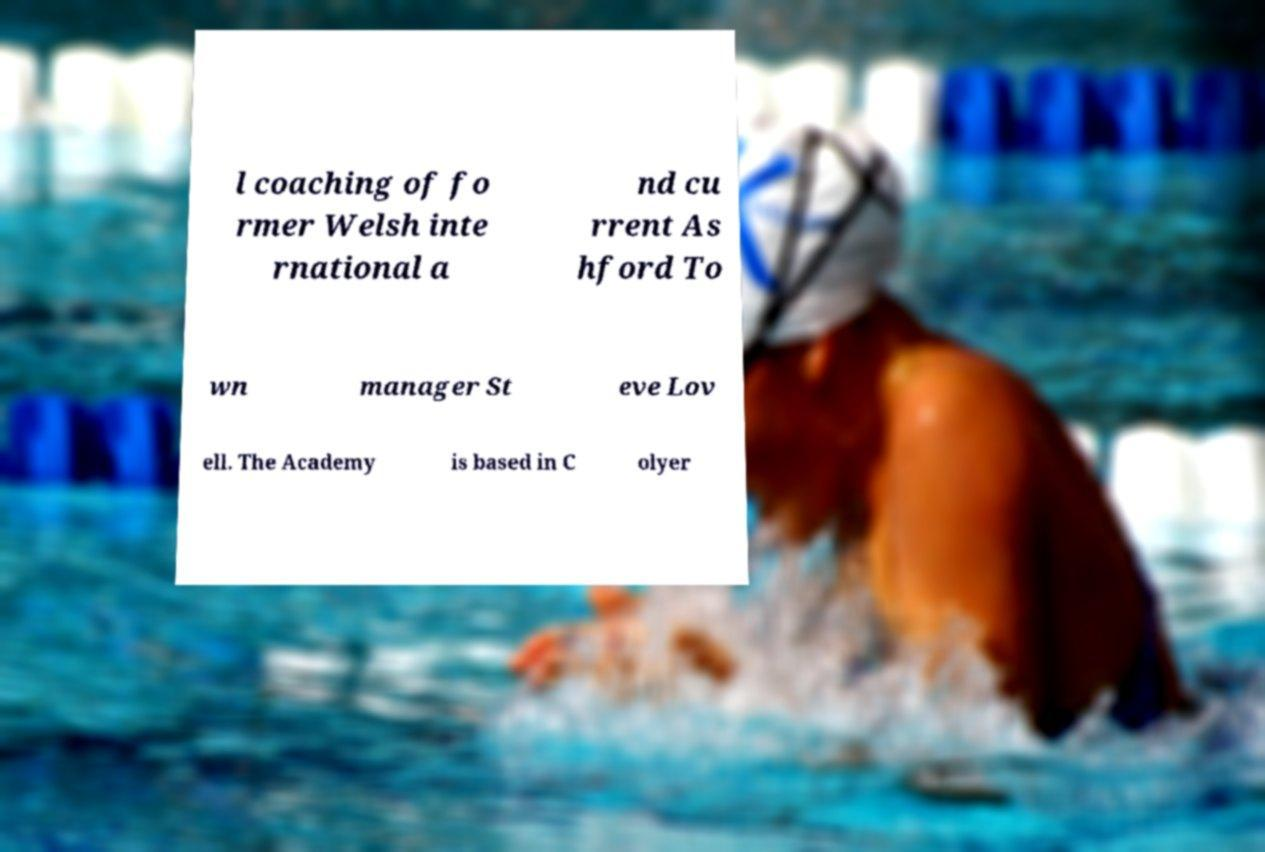Please identify and transcribe the text found in this image. l coaching of fo rmer Welsh inte rnational a nd cu rrent As hford To wn manager St eve Lov ell. The Academy is based in C olyer 